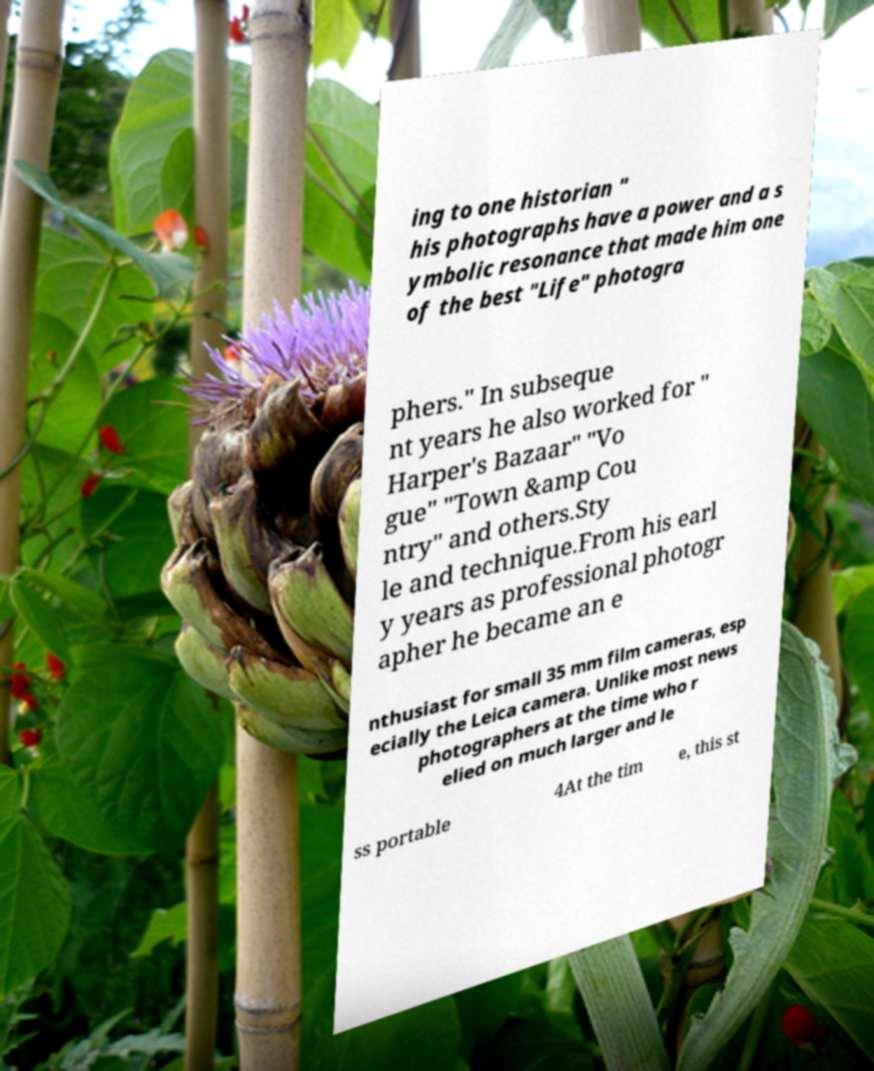Could you extract and type out the text from this image? ing to one historian " his photographs have a power and a s ymbolic resonance that made him one of the best "Life" photogra phers." In subseque nt years he also worked for " Harper's Bazaar" "Vo gue" "Town &amp Cou ntry" and others.Sty le and technique.From his earl y years as professional photogr apher he became an e nthusiast for small 35 mm film cameras, esp ecially the Leica camera. Unlike most news photographers at the time who r elied on much larger and le ss portable 4At the tim e, this st 